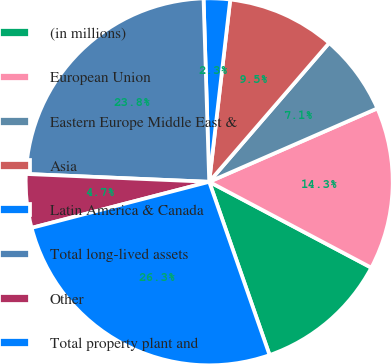<chart> <loc_0><loc_0><loc_500><loc_500><pie_chart><fcel>(in millions)<fcel>European Union<fcel>Eastern Europe Middle East &<fcel>Asia<fcel>Latin America & Canada<fcel>Total long-lived assets<fcel>Other<fcel>Total property plant and<nl><fcel>11.91%<fcel>14.31%<fcel>7.11%<fcel>9.51%<fcel>2.32%<fcel>23.83%<fcel>4.72%<fcel>26.3%<nl></chart> 